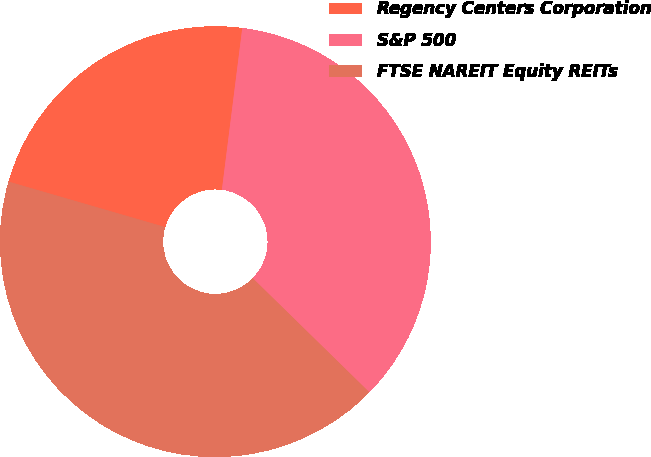Convert chart. <chart><loc_0><loc_0><loc_500><loc_500><pie_chart><fcel>Regency Centers Corporation<fcel>S&P 500<fcel>FTSE NAREIT Equity REITs<nl><fcel>22.5%<fcel>35.33%<fcel>42.17%<nl></chart> 